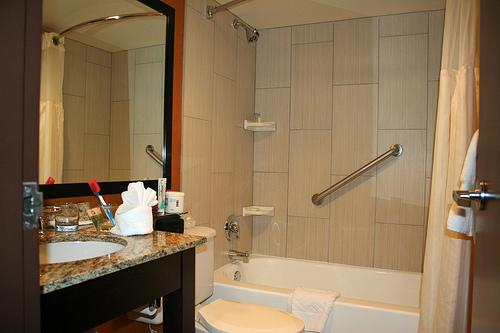Question: what room is this?
Choices:
A. Bedroom.
B. Kitchen.
C. Parlour.
D. Bathroom.
Answer with the letter. Answer: D Question: what color is the toothbrush cover?
Choices:
A. Blue.
B. Green.
C. Yellow.
D. Red.
Answer with the letter. Answer: D Question: how is the curtain rod shaped?
Choices:
A. Straight.
B. Curly.
C. Curved.
D. Circular.
Answer with the letter. Answer: C Question: how many towels are in the photo?
Choices:
A. One.
B. Three.
C. Two.
D. Four.
Answer with the letter. Answer: B 